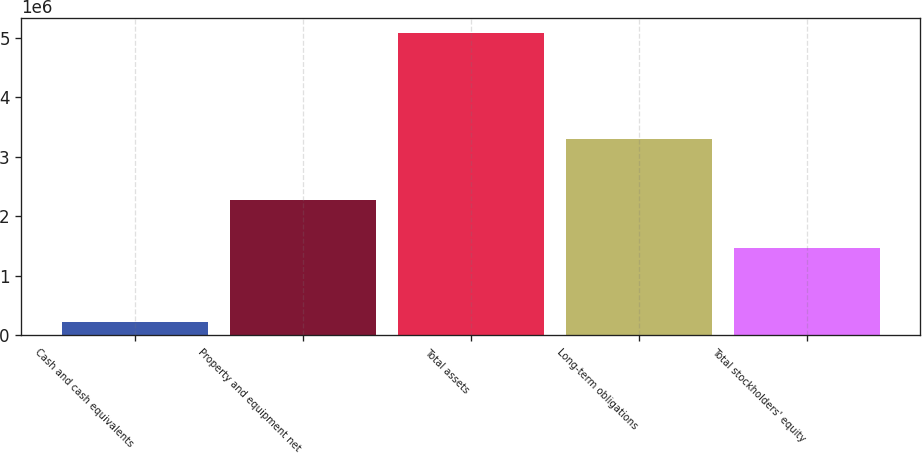<chart> <loc_0><loc_0><loc_500><loc_500><bar_chart><fcel>Cash and cash equivalents<fcel>Property and equipment net<fcel>Total assets<fcel>Long-term obligations<fcel>Total stockholders' equity<nl><fcel>215557<fcel>2.27336e+06<fcel>5.08597e+06<fcel>3.29361e+06<fcel>1.47095e+06<nl></chart> 